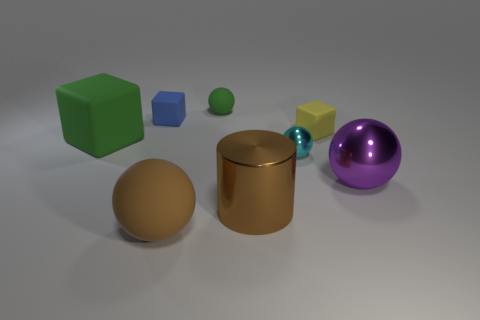Is the shape of the big rubber object in front of the tiny metal sphere the same as  the cyan metal object?
Give a very brief answer. Yes. Are there more small metal things that are in front of the cyan ball than brown spheres?
Your response must be concise. No. Are there any other things that are made of the same material as the yellow cube?
Provide a short and direct response. Yes. The big rubber object that is the same color as the cylinder is what shape?
Offer a very short reply. Sphere. How many spheres are either green rubber things or metal things?
Provide a short and direct response. 3. There is a rubber ball that is right of the big matte thing that is in front of the tiny cyan metal ball; what color is it?
Your response must be concise. Green. There is a cylinder; does it have the same color as the small cube that is left of the brown metallic object?
Provide a short and direct response. No. What is the size of the brown thing that is the same material as the purple ball?
Your answer should be very brief. Large. What size is the rubber ball that is the same color as the large metal cylinder?
Give a very brief answer. Large. Is the color of the cylinder the same as the small metallic thing?
Provide a short and direct response. No. 